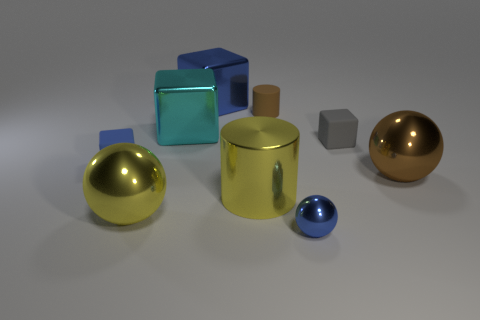There is a yellow sphere; is it the same size as the cylinder that is on the right side of the yellow metallic cylinder?
Offer a very short reply. No. Are there fewer cyan metallic things that are behind the large blue cube than gray spheres?
Your response must be concise. No. How many spheres are the same color as the large metallic cylinder?
Offer a terse response. 1. Are there fewer big cyan blocks than big matte objects?
Ensure brevity in your answer.  No. Is the tiny brown thing made of the same material as the big brown thing?
Offer a terse response. No. How many other things are the same size as the gray block?
Provide a short and direct response. 3. The metal sphere that is behind the sphere left of the large blue cube is what color?
Your answer should be compact. Brown. What number of other things are the same shape as the big cyan shiny thing?
Keep it short and to the point. 3. Is there a big yellow cylinder made of the same material as the large blue cube?
Your answer should be compact. Yes. There is a gray block that is the same size as the blue rubber thing; what material is it?
Your answer should be very brief. Rubber. 